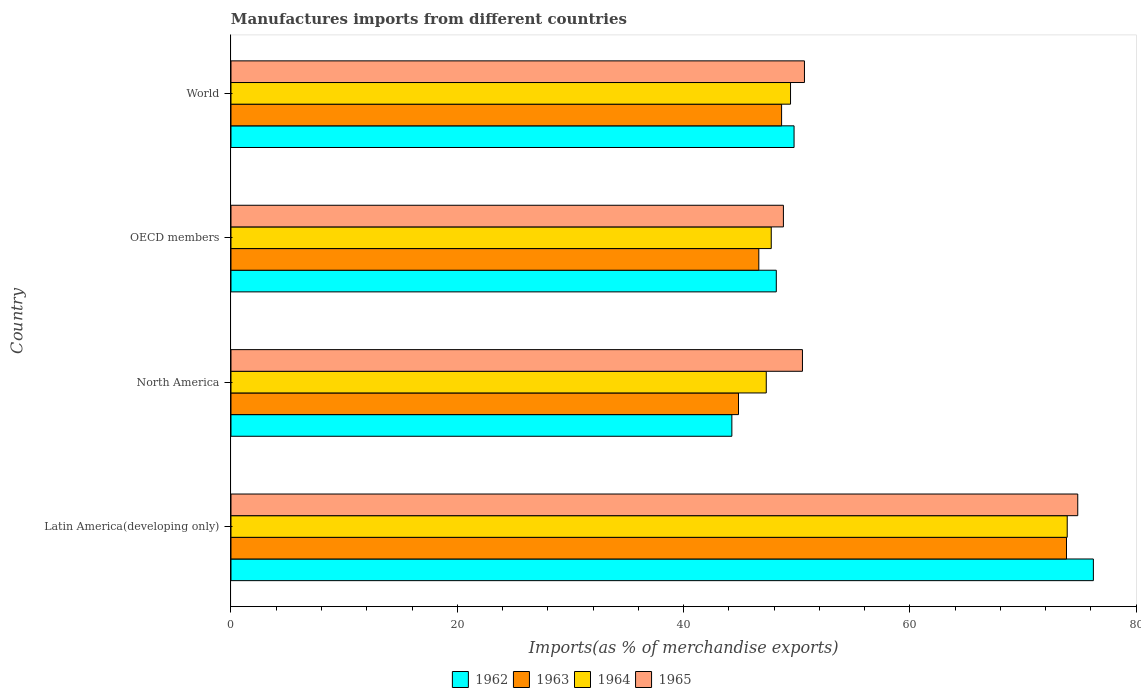How many different coloured bars are there?
Your answer should be very brief. 4. Are the number of bars per tick equal to the number of legend labels?
Provide a succinct answer. Yes. Are the number of bars on each tick of the Y-axis equal?
Provide a succinct answer. Yes. How many bars are there on the 2nd tick from the top?
Offer a very short reply. 4. What is the percentage of imports to different countries in 1963 in North America?
Give a very brief answer. 44.85. Across all countries, what is the maximum percentage of imports to different countries in 1963?
Provide a succinct answer. 73.84. Across all countries, what is the minimum percentage of imports to different countries in 1965?
Provide a short and direct response. 48.82. In which country was the percentage of imports to different countries in 1964 maximum?
Keep it short and to the point. Latin America(developing only). What is the total percentage of imports to different countries in 1965 in the graph?
Ensure brevity in your answer.  224.83. What is the difference between the percentage of imports to different countries in 1962 in Latin America(developing only) and that in OECD members?
Give a very brief answer. 28.02. What is the difference between the percentage of imports to different countries in 1964 in North America and the percentage of imports to different countries in 1965 in World?
Offer a terse response. -3.37. What is the average percentage of imports to different countries in 1965 per country?
Keep it short and to the point. 56.21. What is the difference between the percentage of imports to different countries in 1965 and percentage of imports to different countries in 1964 in World?
Offer a very short reply. 1.23. In how many countries, is the percentage of imports to different countries in 1964 greater than 60 %?
Offer a terse response. 1. What is the ratio of the percentage of imports to different countries in 1964 in OECD members to that in World?
Keep it short and to the point. 0.97. Is the percentage of imports to different countries in 1965 in Latin America(developing only) less than that in OECD members?
Your answer should be very brief. No. What is the difference between the highest and the second highest percentage of imports to different countries in 1962?
Your response must be concise. 26.45. What is the difference between the highest and the lowest percentage of imports to different countries in 1962?
Give a very brief answer. 31.95. In how many countries, is the percentage of imports to different countries in 1962 greater than the average percentage of imports to different countries in 1962 taken over all countries?
Offer a terse response. 1. What does the 4th bar from the bottom in Latin America(developing only) represents?
Your answer should be very brief. 1965. Is it the case that in every country, the sum of the percentage of imports to different countries in 1962 and percentage of imports to different countries in 1964 is greater than the percentage of imports to different countries in 1963?
Provide a succinct answer. Yes. Are all the bars in the graph horizontal?
Your answer should be compact. Yes. How many countries are there in the graph?
Provide a short and direct response. 4. What is the difference between two consecutive major ticks on the X-axis?
Provide a succinct answer. 20. How are the legend labels stacked?
Offer a terse response. Horizontal. What is the title of the graph?
Provide a succinct answer. Manufactures imports from different countries. What is the label or title of the X-axis?
Keep it short and to the point. Imports(as % of merchandise exports). What is the Imports(as % of merchandise exports) in 1962 in Latin America(developing only)?
Offer a terse response. 76.21. What is the Imports(as % of merchandise exports) of 1963 in Latin America(developing only)?
Offer a very short reply. 73.84. What is the Imports(as % of merchandise exports) of 1964 in Latin America(developing only)?
Ensure brevity in your answer.  73.9. What is the Imports(as % of merchandise exports) in 1965 in Latin America(developing only)?
Provide a succinct answer. 74.83. What is the Imports(as % of merchandise exports) in 1962 in North America?
Make the answer very short. 44.26. What is the Imports(as % of merchandise exports) in 1963 in North America?
Ensure brevity in your answer.  44.85. What is the Imports(as % of merchandise exports) in 1964 in North America?
Provide a succinct answer. 47.3. What is the Imports(as % of merchandise exports) in 1965 in North America?
Your answer should be compact. 50.5. What is the Imports(as % of merchandise exports) in 1962 in OECD members?
Your answer should be compact. 48.19. What is the Imports(as % of merchandise exports) of 1963 in OECD members?
Offer a terse response. 46.65. What is the Imports(as % of merchandise exports) in 1964 in OECD members?
Provide a succinct answer. 47.75. What is the Imports(as % of merchandise exports) in 1965 in OECD members?
Ensure brevity in your answer.  48.82. What is the Imports(as % of merchandise exports) in 1962 in World?
Give a very brief answer. 49.76. What is the Imports(as % of merchandise exports) in 1963 in World?
Ensure brevity in your answer.  48.66. What is the Imports(as % of merchandise exports) of 1964 in World?
Your answer should be very brief. 49.45. What is the Imports(as % of merchandise exports) in 1965 in World?
Your answer should be compact. 50.68. Across all countries, what is the maximum Imports(as % of merchandise exports) in 1962?
Keep it short and to the point. 76.21. Across all countries, what is the maximum Imports(as % of merchandise exports) of 1963?
Offer a terse response. 73.84. Across all countries, what is the maximum Imports(as % of merchandise exports) in 1964?
Make the answer very short. 73.9. Across all countries, what is the maximum Imports(as % of merchandise exports) in 1965?
Give a very brief answer. 74.83. Across all countries, what is the minimum Imports(as % of merchandise exports) of 1962?
Your answer should be compact. 44.26. Across all countries, what is the minimum Imports(as % of merchandise exports) in 1963?
Offer a very short reply. 44.85. Across all countries, what is the minimum Imports(as % of merchandise exports) in 1964?
Offer a very short reply. 47.3. Across all countries, what is the minimum Imports(as % of merchandise exports) of 1965?
Ensure brevity in your answer.  48.82. What is the total Imports(as % of merchandise exports) in 1962 in the graph?
Your answer should be compact. 218.43. What is the total Imports(as % of merchandise exports) in 1963 in the graph?
Ensure brevity in your answer.  213.99. What is the total Imports(as % of merchandise exports) of 1964 in the graph?
Offer a very short reply. 218.4. What is the total Imports(as % of merchandise exports) of 1965 in the graph?
Give a very brief answer. 224.83. What is the difference between the Imports(as % of merchandise exports) of 1962 in Latin America(developing only) and that in North America?
Your answer should be very brief. 31.95. What is the difference between the Imports(as % of merchandise exports) in 1963 in Latin America(developing only) and that in North America?
Keep it short and to the point. 28.99. What is the difference between the Imports(as % of merchandise exports) in 1964 in Latin America(developing only) and that in North America?
Give a very brief answer. 26.6. What is the difference between the Imports(as % of merchandise exports) in 1965 in Latin America(developing only) and that in North America?
Provide a succinct answer. 24.33. What is the difference between the Imports(as % of merchandise exports) of 1962 in Latin America(developing only) and that in OECD members?
Give a very brief answer. 28.02. What is the difference between the Imports(as % of merchandise exports) of 1963 in Latin America(developing only) and that in OECD members?
Your answer should be compact. 27.19. What is the difference between the Imports(as % of merchandise exports) of 1964 in Latin America(developing only) and that in OECD members?
Provide a short and direct response. 26.16. What is the difference between the Imports(as % of merchandise exports) of 1965 in Latin America(developing only) and that in OECD members?
Your response must be concise. 26.01. What is the difference between the Imports(as % of merchandise exports) of 1962 in Latin America(developing only) and that in World?
Give a very brief answer. 26.45. What is the difference between the Imports(as % of merchandise exports) in 1963 in Latin America(developing only) and that in World?
Ensure brevity in your answer.  25.18. What is the difference between the Imports(as % of merchandise exports) in 1964 in Latin America(developing only) and that in World?
Provide a short and direct response. 24.45. What is the difference between the Imports(as % of merchandise exports) in 1965 in Latin America(developing only) and that in World?
Your response must be concise. 24.15. What is the difference between the Imports(as % of merchandise exports) in 1962 in North America and that in OECD members?
Keep it short and to the point. -3.93. What is the difference between the Imports(as % of merchandise exports) of 1963 in North America and that in OECD members?
Ensure brevity in your answer.  -1.8. What is the difference between the Imports(as % of merchandise exports) in 1964 in North America and that in OECD members?
Your answer should be compact. -0.44. What is the difference between the Imports(as % of merchandise exports) of 1965 in North America and that in OECD members?
Make the answer very short. 1.68. What is the difference between the Imports(as % of merchandise exports) of 1962 in North America and that in World?
Your response must be concise. -5.5. What is the difference between the Imports(as % of merchandise exports) in 1963 in North America and that in World?
Make the answer very short. -3.81. What is the difference between the Imports(as % of merchandise exports) in 1964 in North America and that in World?
Give a very brief answer. -2.14. What is the difference between the Imports(as % of merchandise exports) of 1965 in North America and that in World?
Give a very brief answer. -0.18. What is the difference between the Imports(as % of merchandise exports) in 1962 in OECD members and that in World?
Give a very brief answer. -1.57. What is the difference between the Imports(as % of merchandise exports) of 1963 in OECD members and that in World?
Your answer should be very brief. -2.01. What is the difference between the Imports(as % of merchandise exports) in 1964 in OECD members and that in World?
Your response must be concise. -1.7. What is the difference between the Imports(as % of merchandise exports) in 1965 in OECD members and that in World?
Keep it short and to the point. -1.86. What is the difference between the Imports(as % of merchandise exports) in 1962 in Latin America(developing only) and the Imports(as % of merchandise exports) in 1963 in North America?
Give a very brief answer. 31.36. What is the difference between the Imports(as % of merchandise exports) in 1962 in Latin America(developing only) and the Imports(as % of merchandise exports) in 1964 in North America?
Provide a succinct answer. 28.91. What is the difference between the Imports(as % of merchandise exports) in 1962 in Latin America(developing only) and the Imports(as % of merchandise exports) in 1965 in North America?
Give a very brief answer. 25.71. What is the difference between the Imports(as % of merchandise exports) of 1963 in Latin America(developing only) and the Imports(as % of merchandise exports) of 1964 in North America?
Offer a terse response. 26.53. What is the difference between the Imports(as % of merchandise exports) of 1963 in Latin America(developing only) and the Imports(as % of merchandise exports) of 1965 in North America?
Offer a very short reply. 23.34. What is the difference between the Imports(as % of merchandise exports) in 1964 in Latin America(developing only) and the Imports(as % of merchandise exports) in 1965 in North America?
Give a very brief answer. 23.4. What is the difference between the Imports(as % of merchandise exports) of 1962 in Latin America(developing only) and the Imports(as % of merchandise exports) of 1963 in OECD members?
Your response must be concise. 29.57. What is the difference between the Imports(as % of merchandise exports) of 1962 in Latin America(developing only) and the Imports(as % of merchandise exports) of 1964 in OECD members?
Make the answer very short. 28.47. What is the difference between the Imports(as % of merchandise exports) in 1962 in Latin America(developing only) and the Imports(as % of merchandise exports) in 1965 in OECD members?
Your answer should be compact. 27.39. What is the difference between the Imports(as % of merchandise exports) of 1963 in Latin America(developing only) and the Imports(as % of merchandise exports) of 1964 in OECD members?
Ensure brevity in your answer.  26.09. What is the difference between the Imports(as % of merchandise exports) in 1963 in Latin America(developing only) and the Imports(as % of merchandise exports) in 1965 in OECD members?
Your answer should be compact. 25.02. What is the difference between the Imports(as % of merchandise exports) in 1964 in Latin America(developing only) and the Imports(as % of merchandise exports) in 1965 in OECD members?
Offer a very short reply. 25.08. What is the difference between the Imports(as % of merchandise exports) in 1962 in Latin America(developing only) and the Imports(as % of merchandise exports) in 1963 in World?
Offer a very short reply. 27.55. What is the difference between the Imports(as % of merchandise exports) in 1962 in Latin America(developing only) and the Imports(as % of merchandise exports) in 1964 in World?
Keep it short and to the point. 26.76. What is the difference between the Imports(as % of merchandise exports) in 1962 in Latin America(developing only) and the Imports(as % of merchandise exports) in 1965 in World?
Provide a short and direct response. 25.53. What is the difference between the Imports(as % of merchandise exports) of 1963 in Latin America(developing only) and the Imports(as % of merchandise exports) of 1964 in World?
Your response must be concise. 24.39. What is the difference between the Imports(as % of merchandise exports) of 1963 in Latin America(developing only) and the Imports(as % of merchandise exports) of 1965 in World?
Your answer should be very brief. 23.16. What is the difference between the Imports(as % of merchandise exports) of 1964 in Latin America(developing only) and the Imports(as % of merchandise exports) of 1965 in World?
Provide a short and direct response. 23.22. What is the difference between the Imports(as % of merchandise exports) of 1962 in North America and the Imports(as % of merchandise exports) of 1963 in OECD members?
Give a very brief answer. -2.38. What is the difference between the Imports(as % of merchandise exports) of 1962 in North America and the Imports(as % of merchandise exports) of 1964 in OECD members?
Make the answer very short. -3.48. What is the difference between the Imports(as % of merchandise exports) in 1962 in North America and the Imports(as % of merchandise exports) in 1965 in OECD members?
Keep it short and to the point. -4.56. What is the difference between the Imports(as % of merchandise exports) of 1963 in North America and the Imports(as % of merchandise exports) of 1964 in OECD members?
Your answer should be compact. -2.89. What is the difference between the Imports(as % of merchandise exports) in 1963 in North America and the Imports(as % of merchandise exports) in 1965 in OECD members?
Provide a succinct answer. -3.97. What is the difference between the Imports(as % of merchandise exports) of 1964 in North America and the Imports(as % of merchandise exports) of 1965 in OECD members?
Offer a very short reply. -1.52. What is the difference between the Imports(as % of merchandise exports) in 1962 in North America and the Imports(as % of merchandise exports) in 1963 in World?
Your response must be concise. -4.4. What is the difference between the Imports(as % of merchandise exports) of 1962 in North America and the Imports(as % of merchandise exports) of 1964 in World?
Your answer should be compact. -5.19. What is the difference between the Imports(as % of merchandise exports) in 1962 in North America and the Imports(as % of merchandise exports) in 1965 in World?
Offer a terse response. -6.42. What is the difference between the Imports(as % of merchandise exports) in 1963 in North America and the Imports(as % of merchandise exports) in 1964 in World?
Give a very brief answer. -4.6. What is the difference between the Imports(as % of merchandise exports) of 1963 in North America and the Imports(as % of merchandise exports) of 1965 in World?
Offer a terse response. -5.83. What is the difference between the Imports(as % of merchandise exports) in 1964 in North America and the Imports(as % of merchandise exports) in 1965 in World?
Keep it short and to the point. -3.37. What is the difference between the Imports(as % of merchandise exports) of 1962 in OECD members and the Imports(as % of merchandise exports) of 1963 in World?
Offer a very short reply. -0.47. What is the difference between the Imports(as % of merchandise exports) in 1962 in OECD members and the Imports(as % of merchandise exports) in 1964 in World?
Offer a terse response. -1.26. What is the difference between the Imports(as % of merchandise exports) in 1962 in OECD members and the Imports(as % of merchandise exports) in 1965 in World?
Keep it short and to the point. -2.49. What is the difference between the Imports(as % of merchandise exports) in 1963 in OECD members and the Imports(as % of merchandise exports) in 1964 in World?
Your answer should be very brief. -2.8. What is the difference between the Imports(as % of merchandise exports) in 1963 in OECD members and the Imports(as % of merchandise exports) in 1965 in World?
Provide a succinct answer. -4.03. What is the difference between the Imports(as % of merchandise exports) of 1964 in OECD members and the Imports(as % of merchandise exports) of 1965 in World?
Keep it short and to the point. -2.93. What is the average Imports(as % of merchandise exports) in 1962 per country?
Your answer should be compact. 54.61. What is the average Imports(as % of merchandise exports) of 1963 per country?
Give a very brief answer. 53.5. What is the average Imports(as % of merchandise exports) of 1964 per country?
Your answer should be compact. 54.6. What is the average Imports(as % of merchandise exports) in 1965 per country?
Your answer should be compact. 56.21. What is the difference between the Imports(as % of merchandise exports) in 1962 and Imports(as % of merchandise exports) in 1963 in Latin America(developing only)?
Make the answer very short. 2.37. What is the difference between the Imports(as % of merchandise exports) in 1962 and Imports(as % of merchandise exports) in 1964 in Latin America(developing only)?
Offer a terse response. 2.31. What is the difference between the Imports(as % of merchandise exports) in 1962 and Imports(as % of merchandise exports) in 1965 in Latin America(developing only)?
Your answer should be compact. 1.38. What is the difference between the Imports(as % of merchandise exports) of 1963 and Imports(as % of merchandise exports) of 1964 in Latin America(developing only)?
Keep it short and to the point. -0.06. What is the difference between the Imports(as % of merchandise exports) of 1963 and Imports(as % of merchandise exports) of 1965 in Latin America(developing only)?
Offer a terse response. -0.99. What is the difference between the Imports(as % of merchandise exports) of 1964 and Imports(as % of merchandise exports) of 1965 in Latin America(developing only)?
Your answer should be compact. -0.93. What is the difference between the Imports(as % of merchandise exports) of 1962 and Imports(as % of merchandise exports) of 1963 in North America?
Your answer should be compact. -0.59. What is the difference between the Imports(as % of merchandise exports) of 1962 and Imports(as % of merchandise exports) of 1964 in North America?
Provide a succinct answer. -3.04. What is the difference between the Imports(as % of merchandise exports) in 1962 and Imports(as % of merchandise exports) in 1965 in North America?
Provide a short and direct response. -6.24. What is the difference between the Imports(as % of merchandise exports) of 1963 and Imports(as % of merchandise exports) of 1964 in North America?
Provide a short and direct response. -2.45. What is the difference between the Imports(as % of merchandise exports) in 1963 and Imports(as % of merchandise exports) in 1965 in North America?
Your answer should be compact. -5.65. What is the difference between the Imports(as % of merchandise exports) in 1964 and Imports(as % of merchandise exports) in 1965 in North America?
Offer a terse response. -3.2. What is the difference between the Imports(as % of merchandise exports) of 1962 and Imports(as % of merchandise exports) of 1963 in OECD members?
Provide a succinct answer. 1.55. What is the difference between the Imports(as % of merchandise exports) of 1962 and Imports(as % of merchandise exports) of 1964 in OECD members?
Offer a very short reply. 0.45. What is the difference between the Imports(as % of merchandise exports) of 1962 and Imports(as % of merchandise exports) of 1965 in OECD members?
Your answer should be very brief. -0.63. What is the difference between the Imports(as % of merchandise exports) in 1963 and Imports(as % of merchandise exports) in 1964 in OECD members?
Your response must be concise. -1.1. What is the difference between the Imports(as % of merchandise exports) of 1963 and Imports(as % of merchandise exports) of 1965 in OECD members?
Provide a short and direct response. -2.17. What is the difference between the Imports(as % of merchandise exports) in 1964 and Imports(as % of merchandise exports) in 1965 in OECD members?
Provide a short and direct response. -1.07. What is the difference between the Imports(as % of merchandise exports) of 1962 and Imports(as % of merchandise exports) of 1963 in World?
Your answer should be very brief. 1.1. What is the difference between the Imports(as % of merchandise exports) in 1962 and Imports(as % of merchandise exports) in 1964 in World?
Your answer should be compact. 0.31. What is the difference between the Imports(as % of merchandise exports) of 1962 and Imports(as % of merchandise exports) of 1965 in World?
Provide a succinct answer. -0.92. What is the difference between the Imports(as % of merchandise exports) of 1963 and Imports(as % of merchandise exports) of 1964 in World?
Offer a very short reply. -0.79. What is the difference between the Imports(as % of merchandise exports) in 1963 and Imports(as % of merchandise exports) in 1965 in World?
Give a very brief answer. -2.02. What is the difference between the Imports(as % of merchandise exports) in 1964 and Imports(as % of merchandise exports) in 1965 in World?
Provide a short and direct response. -1.23. What is the ratio of the Imports(as % of merchandise exports) in 1962 in Latin America(developing only) to that in North America?
Provide a short and direct response. 1.72. What is the ratio of the Imports(as % of merchandise exports) of 1963 in Latin America(developing only) to that in North America?
Ensure brevity in your answer.  1.65. What is the ratio of the Imports(as % of merchandise exports) in 1964 in Latin America(developing only) to that in North America?
Provide a short and direct response. 1.56. What is the ratio of the Imports(as % of merchandise exports) in 1965 in Latin America(developing only) to that in North America?
Provide a succinct answer. 1.48. What is the ratio of the Imports(as % of merchandise exports) of 1962 in Latin America(developing only) to that in OECD members?
Provide a short and direct response. 1.58. What is the ratio of the Imports(as % of merchandise exports) in 1963 in Latin America(developing only) to that in OECD members?
Provide a short and direct response. 1.58. What is the ratio of the Imports(as % of merchandise exports) of 1964 in Latin America(developing only) to that in OECD members?
Provide a short and direct response. 1.55. What is the ratio of the Imports(as % of merchandise exports) of 1965 in Latin America(developing only) to that in OECD members?
Your response must be concise. 1.53. What is the ratio of the Imports(as % of merchandise exports) of 1962 in Latin America(developing only) to that in World?
Your answer should be very brief. 1.53. What is the ratio of the Imports(as % of merchandise exports) of 1963 in Latin America(developing only) to that in World?
Offer a terse response. 1.52. What is the ratio of the Imports(as % of merchandise exports) in 1964 in Latin America(developing only) to that in World?
Your response must be concise. 1.49. What is the ratio of the Imports(as % of merchandise exports) in 1965 in Latin America(developing only) to that in World?
Your answer should be compact. 1.48. What is the ratio of the Imports(as % of merchandise exports) in 1962 in North America to that in OECD members?
Offer a very short reply. 0.92. What is the ratio of the Imports(as % of merchandise exports) in 1963 in North America to that in OECD members?
Provide a succinct answer. 0.96. What is the ratio of the Imports(as % of merchandise exports) in 1965 in North America to that in OECD members?
Give a very brief answer. 1.03. What is the ratio of the Imports(as % of merchandise exports) of 1962 in North America to that in World?
Make the answer very short. 0.89. What is the ratio of the Imports(as % of merchandise exports) in 1963 in North America to that in World?
Offer a very short reply. 0.92. What is the ratio of the Imports(as % of merchandise exports) in 1964 in North America to that in World?
Make the answer very short. 0.96. What is the ratio of the Imports(as % of merchandise exports) in 1965 in North America to that in World?
Your response must be concise. 1. What is the ratio of the Imports(as % of merchandise exports) in 1962 in OECD members to that in World?
Make the answer very short. 0.97. What is the ratio of the Imports(as % of merchandise exports) of 1963 in OECD members to that in World?
Keep it short and to the point. 0.96. What is the ratio of the Imports(as % of merchandise exports) in 1964 in OECD members to that in World?
Provide a succinct answer. 0.97. What is the ratio of the Imports(as % of merchandise exports) of 1965 in OECD members to that in World?
Provide a short and direct response. 0.96. What is the difference between the highest and the second highest Imports(as % of merchandise exports) in 1962?
Give a very brief answer. 26.45. What is the difference between the highest and the second highest Imports(as % of merchandise exports) of 1963?
Offer a terse response. 25.18. What is the difference between the highest and the second highest Imports(as % of merchandise exports) of 1964?
Ensure brevity in your answer.  24.45. What is the difference between the highest and the second highest Imports(as % of merchandise exports) in 1965?
Give a very brief answer. 24.15. What is the difference between the highest and the lowest Imports(as % of merchandise exports) in 1962?
Offer a very short reply. 31.95. What is the difference between the highest and the lowest Imports(as % of merchandise exports) in 1963?
Keep it short and to the point. 28.99. What is the difference between the highest and the lowest Imports(as % of merchandise exports) in 1964?
Your response must be concise. 26.6. What is the difference between the highest and the lowest Imports(as % of merchandise exports) of 1965?
Offer a very short reply. 26.01. 